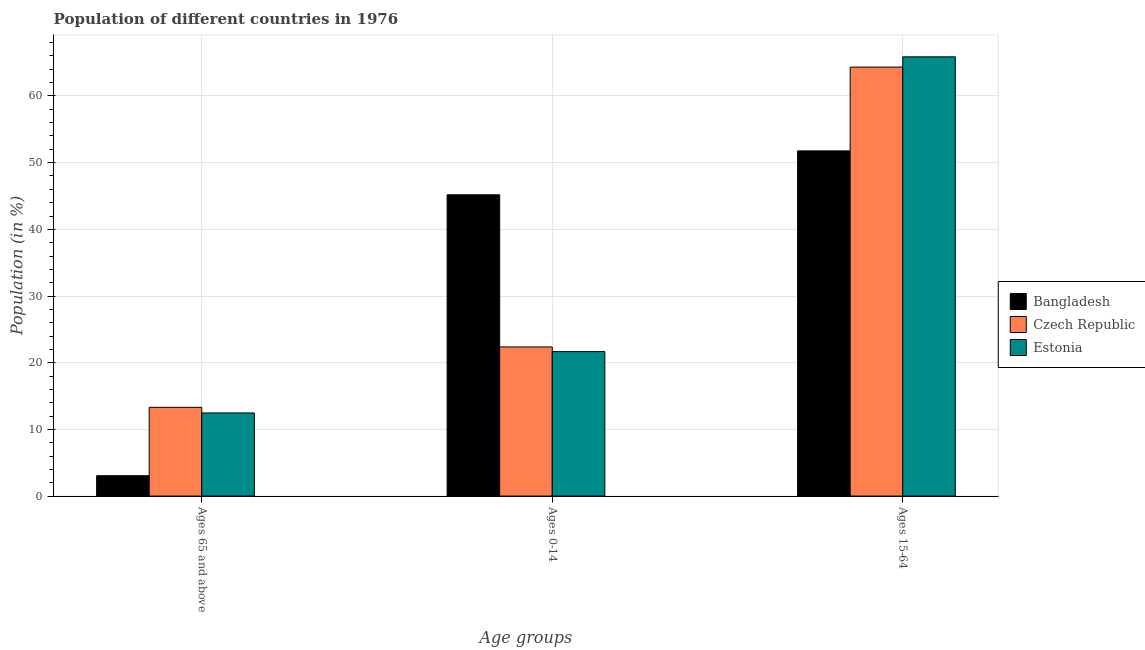How many groups of bars are there?
Your answer should be very brief. 3. Are the number of bars per tick equal to the number of legend labels?
Your answer should be compact. Yes. How many bars are there on the 3rd tick from the left?
Your response must be concise. 3. What is the label of the 3rd group of bars from the left?
Provide a succinct answer. Ages 15-64. What is the percentage of population within the age-group 15-64 in Bangladesh?
Provide a succinct answer. 51.77. Across all countries, what is the maximum percentage of population within the age-group 15-64?
Your answer should be compact. 65.87. Across all countries, what is the minimum percentage of population within the age-group 15-64?
Provide a succinct answer. 51.77. In which country was the percentage of population within the age-group 15-64 minimum?
Keep it short and to the point. Bangladesh. What is the total percentage of population within the age-group of 65 and above in the graph?
Your response must be concise. 28.83. What is the difference between the percentage of population within the age-group 0-14 in Bangladesh and that in Czech Republic?
Your answer should be very brief. 22.82. What is the difference between the percentage of population within the age-group of 65 and above in Estonia and the percentage of population within the age-group 0-14 in Bangladesh?
Make the answer very short. -32.71. What is the average percentage of population within the age-group 15-64 per country?
Your answer should be compact. 60.66. What is the difference between the percentage of population within the age-group 15-64 and percentage of population within the age-group 0-14 in Czech Republic?
Make the answer very short. 41.97. What is the ratio of the percentage of population within the age-group 15-64 in Czech Republic to that in Bangladesh?
Ensure brevity in your answer.  1.24. Is the difference between the percentage of population within the age-group of 65 and above in Bangladesh and Estonia greater than the difference between the percentage of population within the age-group 15-64 in Bangladesh and Estonia?
Make the answer very short. Yes. What is the difference between the highest and the second highest percentage of population within the age-group of 65 and above?
Provide a succinct answer. 0.84. What is the difference between the highest and the lowest percentage of population within the age-group of 65 and above?
Ensure brevity in your answer.  10.25. What does the 2nd bar from the right in Ages 65 and above represents?
Ensure brevity in your answer.  Czech Republic. Is it the case that in every country, the sum of the percentage of population within the age-group of 65 and above and percentage of population within the age-group 0-14 is greater than the percentage of population within the age-group 15-64?
Your response must be concise. No. How many bars are there?
Your answer should be compact. 9. Are all the bars in the graph horizontal?
Provide a short and direct response. No. How many countries are there in the graph?
Ensure brevity in your answer.  3. Does the graph contain any zero values?
Ensure brevity in your answer.  No. Where does the legend appear in the graph?
Provide a short and direct response. Center right. What is the title of the graph?
Your answer should be compact. Population of different countries in 1976. Does "Mauritania" appear as one of the legend labels in the graph?
Your response must be concise. No. What is the label or title of the X-axis?
Keep it short and to the point. Age groups. What is the Population (in %) of Bangladesh in Ages 65 and above?
Provide a succinct answer. 3.06. What is the Population (in %) of Czech Republic in Ages 65 and above?
Your response must be concise. 13.31. What is the Population (in %) of Estonia in Ages 65 and above?
Your answer should be very brief. 12.47. What is the Population (in %) of Bangladesh in Ages 0-14?
Offer a terse response. 45.18. What is the Population (in %) of Czech Republic in Ages 0-14?
Keep it short and to the point. 22.36. What is the Population (in %) of Estonia in Ages 0-14?
Your answer should be very brief. 21.66. What is the Population (in %) in Bangladesh in Ages 15-64?
Your answer should be compact. 51.77. What is the Population (in %) of Czech Republic in Ages 15-64?
Provide a succinct answer. 64.33. What is the Population (in %) in Estonia in Ages 15-64?
Provide a short and direct response. 65.87. Across all Age groups, what is the maximum Population (in %) in Bangladesh?
Give a very brief answer. 51.77. Across all Age groups, what is the maximum Population (in %) in Czech Republic?
Your response must be concise. 64.33. Across all Age groups, what is the maximum Population (in %) of Estonia?
Ensure brevity in your answer.  65.87. Across all Age groups, what is the minimum Population (in %) in Bangladesh?
Your response must be concise. 3.06. Across all Age groups, what is the minimum Population (in %) in Czech Republic?
Provide a short and direct response. 13.31. Across all Age groups, what is the minimum Population (in %) of Estonia?
Your response must be concise. 12.47. What is the total Population (in %) in Bangladesh in the graph?
Your answer should be very brief. 100. What is the total Population (in %) of Estonia in the graph?
Offer a terse response. 100. What is the difference between the Population (in %) in Bangladesh in Ages 65 and above and that in Ages 0-14?
Give a very brief answer. -42.12. What is the difference between the Population (in %) of Czech Republic in Ages 65 and above and that in Ages 0-14?
Provide a succinct answer. -9.06. What is the difference between the Population (in %) in Estonia in Ages 65 and above and that in Ages 0-14?
Keep it short and to the point. -9.2. What is the difference between the Population (in %) in Bangladesh in Ages 65 and above and that in Ages 15-64?
Give a very brief answer. -48.71. What is the difference between the Population (in %) of Czech Republic in Ages 65 and above and that in Ages 15-64?
Provide a succinct answer. -51.03. What is the difference between the Population (in %) in Estonia in Ages 65 and above and that in Ages 15-64?
Offer a very short reply. -53.4. What is the difference between the Population (in %) in Bangladesh in Ages 0-14 and that in Ages 15-64?
Keep it short and to the point. -6.59. What is the difference between the Population (in %) of Czech Republic in Ages 0-14 and that in Ages 15-64?
Offer a terse response. -41.97. What is the difference between the Population (in %) of Estonia in Ages 0-14 and that in Ages 15-64?
Your answer should be compact. -44.2. What is the difference between the Population (in %) of Bangladesh in Ages 65 and above and the Population (in %) of Czech Republic in Ages 0-14?
Give a very brief answer. -19.31. What is the difference between the Population (in %) of Bangladesh in Ages 65 and above and the Population (in %) of Estonia in Ages 0-14?
Provide a succinct answer. -18.61. What is the difference between the Population (in %) in Czech Republic in Ages 65 and above and the Population (in %) in Estonia in Ages 0-14?
Offer a very short reply. -8.36. What is the difference between the Population (in %) in Bangladesh in Ages 65 and above and the Population (in %) in Czech Republic in Ages 15-64?
Offer a terse response. -61.28. What is the difference between the Population (in %) of Bangladesh in Ages 65 and above and the Population (in %) of Estonia in Ages 15-64?
Your answer should be very brief. -62.81. What is the difference between the Population (in %) of Czech Republic in Ages 65 and above and the Population (in %) of Estonia in Ages 15-64?
Offer a very short reply. -52.56. What is the difference between the Population (in %) of Bangladesh in Ages 0-14 and the Population (in %) of Czech Republic in Ages 15-64?
Your answer should be compact. -19.15. What is the difference between the Population (in %) of Bangladesh in Ages 0-14 and the Population (in %) of Estonia in Ages 15-64?
Provide a short and direct response. -20.69. What is the difference between the Population (in %) in Czech Republic in Ages 0-14 and the Population (in %) in Estonia in Ages 15-64?
Make the answer very short. -43.51. What is the average Population (in %) in Bangladesh per Age groups?
Make the answer very short. 33.33. What is the average Population (in %) in Czech Republic per Age groups?
Your answer should be compact. 33.33. What is the average Population (in %) of Estonia per Age groups?
Your answer should be compact. 33.33. What is the difference between the Population (in %) of Bangladesh and Population (in %) of Czech Republic in Ages 65 and above?
Ensure brevity in your answer.  -10.25. What is the difference between the Population (in %) in Bangladesh and Population (in %) in Estonia in Ages 65 and above?
Offer a very short reply. -9.41. What is the difference between the Population (in %) in Czech Republic and Population (in %) in Estonia in Ages 65 and above?
Keep it short and to the point. 0.84. What is the difference between the Population (in %) in Bangladesh and Population (in %) in Czech Republic in Ages 0-14?
Give a very brief answer. 22.82. What is the difference between the Population (in %) of Bangladesh and Population (in %) of Estonia in Ages 0-14?
Provide a short and direct response. 23.51. What is the difference between the Population (in %) in Czech Republic and Population (in %) in Estonia in Ages 0-14?
Your answer should be very brief. 0.7. What is the difference between the Population (in %) of Bangladesh and Population (in %) of Czech Republic in Ages 15-64?
Make the answer very short. -12.57. What is the difference between the Population (in %) of Bangladesh and Population (in %) of Estonia in Ages 15-64?
Your answer should be very brief. -14.1. What is the difference between the Population (in %) in Czech Republic and Population (in %) in Estonia in Ages 15-64?
Your answer should be compact. -1.54. What is the ratio of the Population (in %) in Bangladesh in Ages 65 and above to that in Ages 0-14?
Your answer should be very brief. 0.07. What is the ratio of the Population (in %) in Czech Republic in Ages 65 and above to that in Ages 0-14?
Provide a short and direct response. 0.59. What is the ratio of the Population (in %) of Estonia in Ages 65 and above to that in Ages 0-14?
Make the answer very short. 0.58. What is the ratio of the Population (in %) in Bangladesh in Ages 65 and above to that in Ages 15-64?
Provide a succinct answer. 0.06. What is the ratio of the Population (in %) in Czech Republic in Ages 65 and above to that in Ages 15-64?
Provide a succinct answer. 0.21. What is the ratio of the Population (in %) in Estonia in Ages 65 and above to that in Ages 15-64?
Offer a very short reply. 0.19. What is the ratio of the Population (in %) of Bangladesh in Ages 0-14 to that in Ages 15-64?
Your answer should be very brief. 0.87. What is the ratio of the Population (in %) of Czech Republic in Ages 0-14 to that in Ages 15-64?
Offer a terse response. 0.35. What is the ratio of the Population (in %) in Estonia in Ages 0-14 to that in Ages 15-64?
Provide a succinct answer. 0.33. What is the difference between the highest and the second highest Population (in %) in Bangladesh?
Offer a terse response. 6.59. What is the difference between the highest and the second highest Population (in %) of Czech Republic?
Offer a terse response. 41.97. What is the difference between the highest and the second highest Population (in %) of Estonia?
Make the answer very short. 44.2. What is the difference between the highest and the lowest Population (in %) of Bangladesh?
Keep it short and to the point. 48.71. What is the difference between the highest and the lowest Population (in %) of Czech Republic?
Give a very brief answer. 51.03. What is the difference between the highest and the lowest Population (in %) of Estonia?
Offer a very short reply. 53.4. 